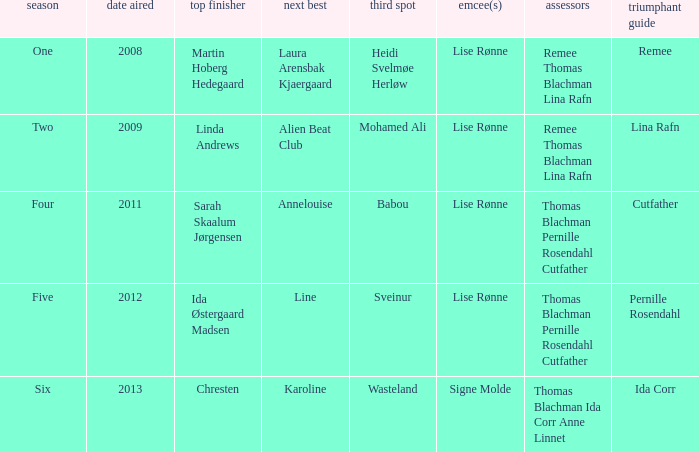Who was the winning mentor in season two? Lina Rafn. 